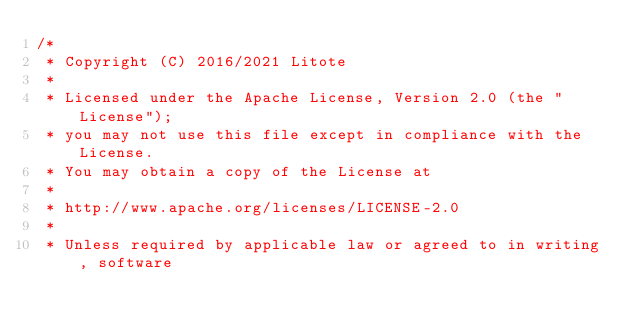Convert code to text. <code><loc_0><loc_0><loc_500><loc_500><_Kotlin_>/*
 * Copyright (C) 2016/2021 Litote
 *
 * Licensed under the Apache License, Version 2.0 (the "License");
 * you may not use this file except in compliance with the License.
 * You may obtain a copy of the License at
 *
 * http://www.apache.org/licenses/LICENSE-2.0
 *
 * Unless required by applicable law or agreed to in writing, software</code> 